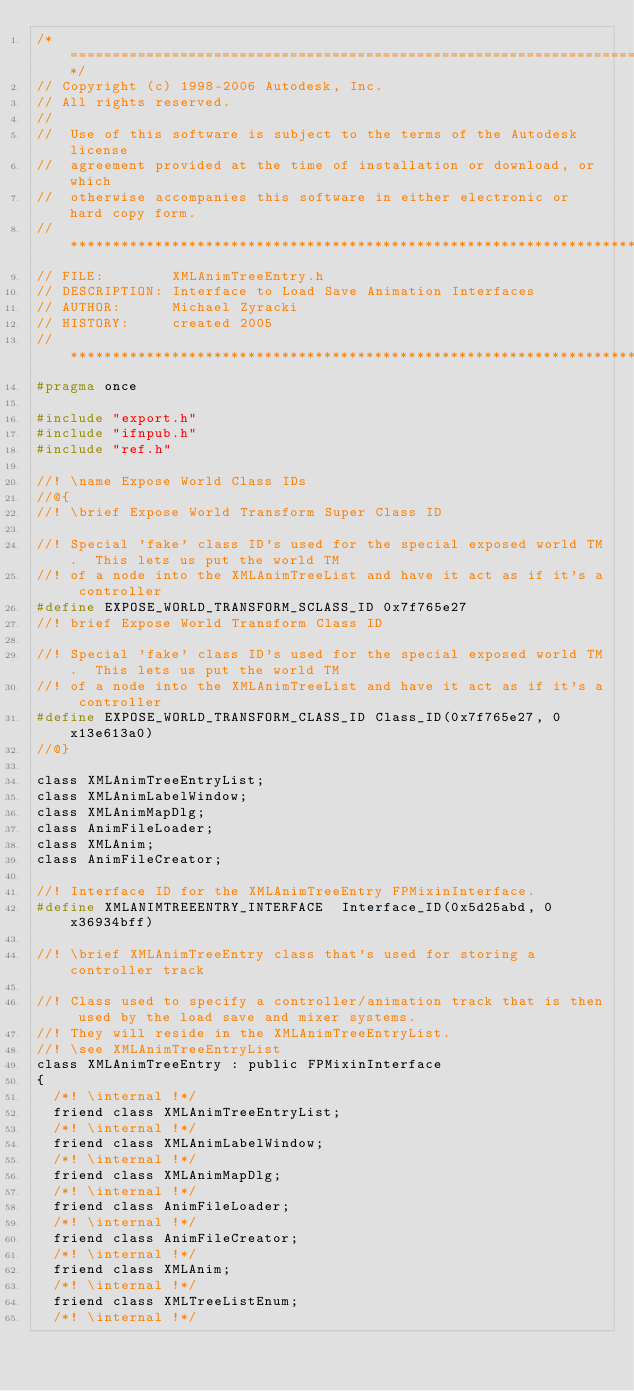<code> <loc_0><loc_0><loc_500><loc_500><_C_>/*============================================================================*/
// Copyright (c) 1998-2006 Autodesk, Inc.
// All rights reserved.
// 
//  Use of this software is subject to the terms of the Autodesk license 
//  agreement provided at the time of installation or download, or which 
//  otherwise accompanies this software in either electronic or hard copy form.
//**************************************************************************/
// FILE:        XMLAnimTreeEntry.h
// DESCRIPTION: Interface to Load Save Animation Interfaces
// AUTHOR:      Michael Zyracki 
// HISTORY:     created 2005
//***************************************************************************/
#pragma once

#include "export.h"
#include "ifnpub.h"
#include "ref.h"

//! \name Expose World Class IDs
//@{
//! \brief Expose World Transform Super Class ID 

//! Special 'fake' class ID's used for the special exposed world TM.  This lets us put the world TM
//! of a node into the XMLAnimTreeList and have it act as if it's a controller
#define EXPOSE_WORLD_TRANSFORM_SCLASS_ID 0x7f765e27
//! brief Expose World Transform Class ID

//! Special 'fake' class ID's used for the special exposed world TM.  This lets us put the world TM
//! of a node into the XMLAnimTreeList and have it act as if it's a controller
#define EXPOSE_WORLD_TRANSFORM_CLASS_ID Class_ID(0x7f765e27, 0x13e613a0) 
//@}

class XMLAnimTreeEntryList;
class XMLAnimLabelWindow;
class XMLAnimMapDlg;
class AnimFileLoader;
class XMLAnim;
class AnimFileCreator;

//! Interface ID for the XMLAnimTreeEntry FPMixinInterface.
#define XMLANIMTREEENTRY_INTERFACE  Interface_ID(0x5d25abd, 0x36934bff)

//! \brief XMLAnimTreeEntry class that's used for storing a controller track

//! Class used to specify a controller/animation track that is then used by the load save and mixer systems.
//! They will reside in the XMLAnimTreeEntryList.
//! \see XMLAnimTreeEntryList
class XMLAnimTreeEntry : public FPMixinInterface
{
	/*! \internal !*/
	friend class XMLAnimTreeEntryList;
	/*! \internal !*/
	friend class XMLAnimLabelWindow;
	/*! \internal !*/
	friend class XMLAnimMapDlg;
	/*! \internal !*/
	friend class AnimFileLoader;
	/*! \internal !*/
	friend class AnimFileCreator;
	/*! \internal !*/
	friend class XMLAnim;
	/*! \internal !*/
	friend class XMLTreeListEnum;
	/*! \internal !*/</code> 